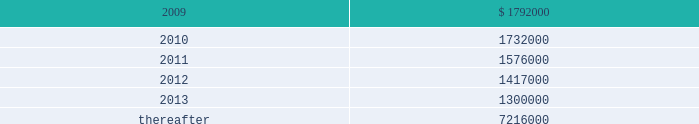Vornado realty trust notes to consolidated financial statements ( continued ) 13 .
Leases as lessor : we lease space to tenants under operating leases .
Most of the leases provide for the payment of fixed base rentals payable monthly in advance .
Office building leases generally require the tenants to reimburse us for operating costs and real estate taxes above their base year costs .
Shopping center leases provide for the pass-through to tenants the tenants 2019 share of real estate taxes , insurance and maintenance .
Shopping center leases also provide for the payment by the lessee of additional rent based on a percentage of the tenants 2019 sales .
As of december 31 , 2008 , future base rental revenue under non-cancelable operating leases , excluding rents for leases with an original term of less than one year and rents resulting from the exercise of renewal options , is as follows : ( amounts in thousands ) year ending december 31: .
These amounts do not include rentals based on tenants 2019 sales .
These percentage rents approximated $ 7322000 , $ 9379000 , and $ 7593000 , for the years ended december 31 , 2008 , 2007 , and 2006 , respectively .
None of our tenants accounted for more than 10% ( 10 % ) of total revenues for the years ended december 31 , 2008 , 2007 and former bradlees locations pursuant to the master agreement and guaranty , dated may 1 , 1992 , we are due $ 5000000 per annum of additional rent from stop & shop which was allocated to certain of bradlees former locations .
On december 31 , 2002 , prior to the expiration of the leases to which the additional rent was allocated , we reallocated this rent to other former bradlees leases also guaranteed by stop & shop .
Stop & shop is contesting our right to reallocate and claims that we are no longer entitled to the additional rent .
At december 31 , 2008 , we are due an aggregate of $ 30400000 .
We believe the additional rent provision of the guaranty expires at the earliest in 2012 and we are vigorously contesting stop & shop 2019s position. .
As of december 31 , 2008 , future base rental revenue under non-cancelable operating leases , excluding rents for leases with an original term of less than one year and rents resulting from the exercise of renewal options , totaled what ( in thousands ) for the years ending december 31 2009 and 2010? 
Computations: (1792000 + 1732000)
Answer: 3524000.0. 